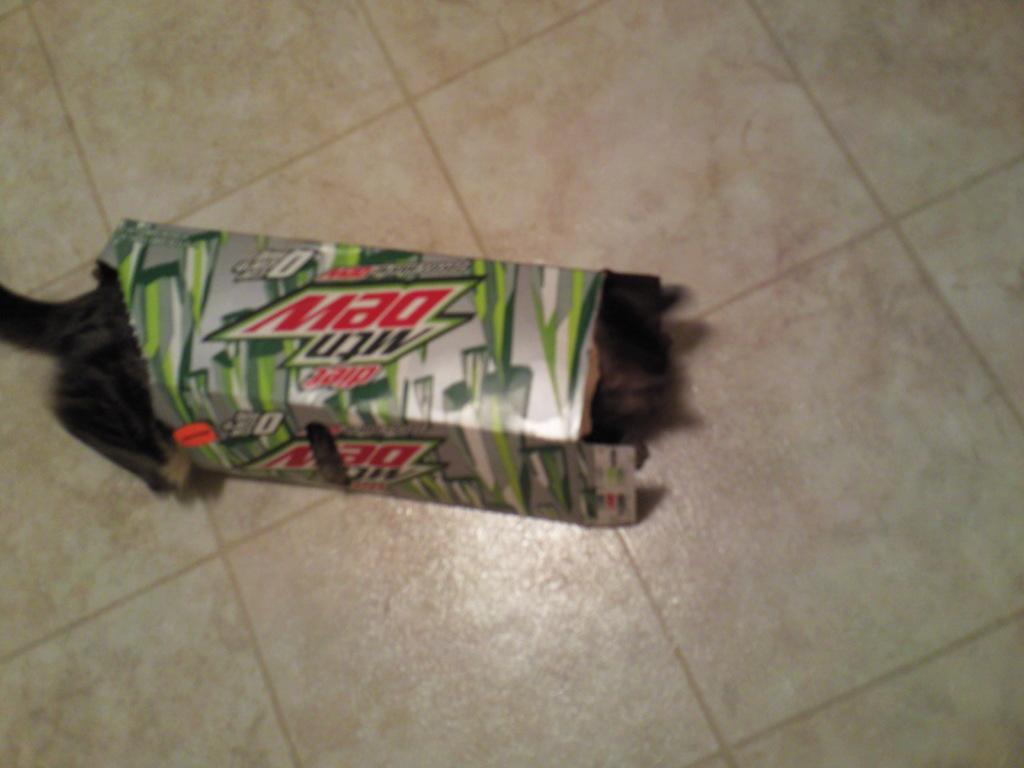In one or two sentences, can you explain what this image depicts? In this image we can see there is a mountain dew box on the floor. 